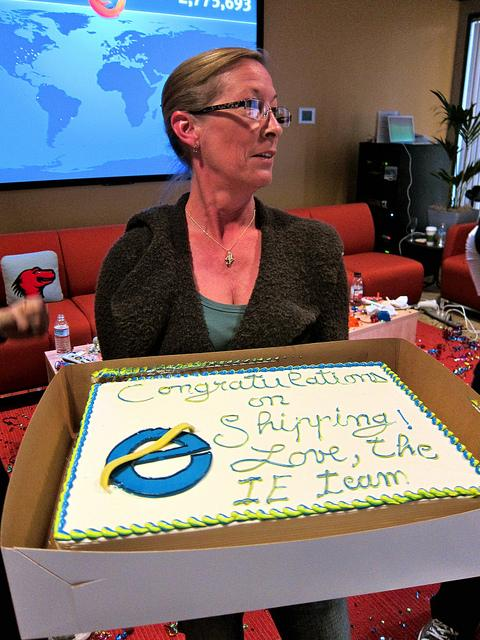Where is this cake and woman located? Please explain your reasoning. tech office. There is an internet explorer logo on the cake. 